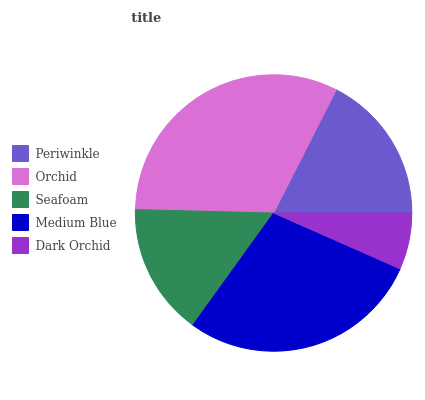Is Dark Orchid the minimum?
Answer yes or no. Yes. Is Orchid the maximum?
Answer yes or no. Yes. Is Seafoam the minimum?
Answer yes or no. No. Is Seafoam the maximum?
Answer yes or no. No. Is Orchid greater than Seafoam?
Answer yes or no. Yes. Is Seafoam less than Orchid?
Answer yes or no. Yes. Is Seafoam greater than Orchid?
Answer yes or no. No. Is Orchid less than Seafoam?
Answer yes or no. No. Is Periwinkle the high median?
Answer yes or no. Yes. Is Periwinkle the low median?
Answer yes or no. Yes. Is Medium Blue the high median?
Answer yes or no. No. Is Seafoam the low median?
Answer yes or no. No. 